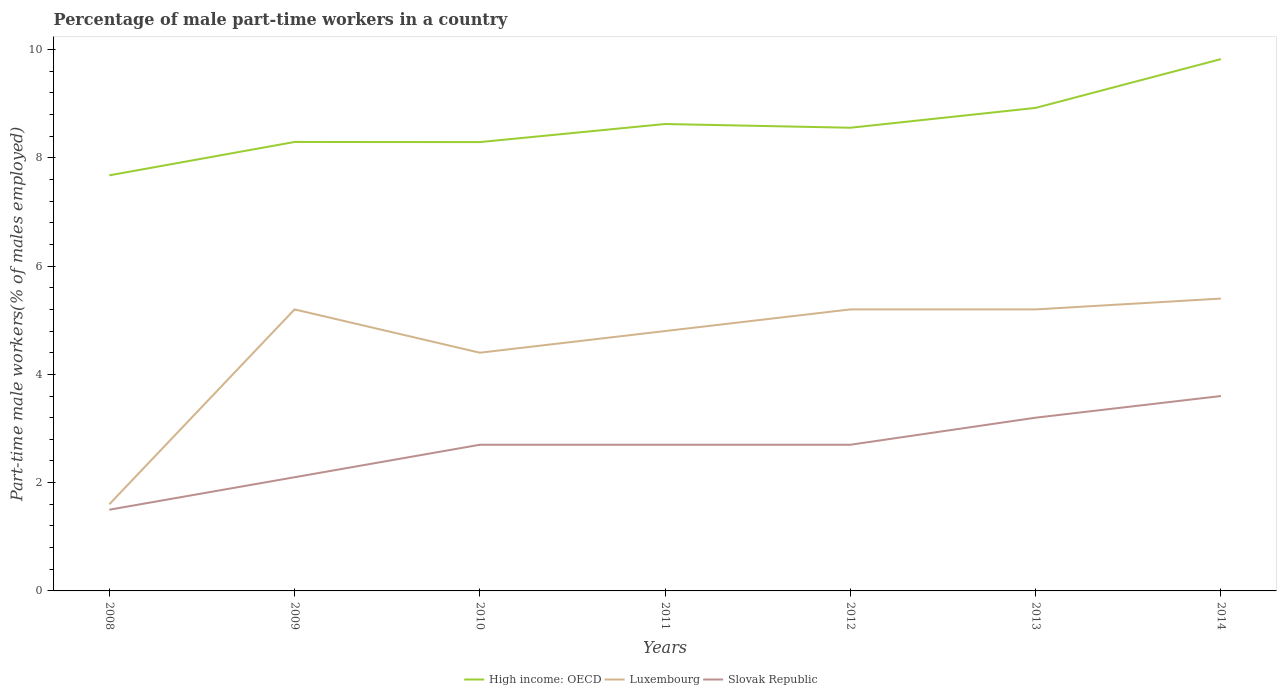Does the line corresponding to High income: OECD intersect with the line corresponding to Slovak Republic?
Your answer should be very brief. No. Is the number of lines equal to the number of legend labels?
Your response must be concise. Yes. Across all years, what is the maximum percentage of male part-time workers in Slovak Republic?
Give a very brief answer. 1.5. In which year was the percentage of male part-time workers in Luxembourg maximum?
Keep it short and to the point. 2008. What is the total percentage of male part-time workers in Luxembourg in the graph?
Your answer should be compact. -2.8. What is the difference between the highest and the second highest percentage of male part-time workers in High income: OECD?
Offer a terse response. 2.15. Is the percentage of male part-time workers in High income: OECD strictly greater than the percentage of male part-time workers in Luxembourg over the years?
Provide a succinct answer. No. How many lines are there?
Give a very brief answer. 3. What is the difference between two consecutive major ticks on the Y-axis?
Provide a short and direct response. 2. Are the values on the major ticks of Y-axis written in scientific E-notation?
Your response must be concise. No. Does the graph contain grids?
Make the answer very short. No. How are the legend labels stacked?
Ensure brevity in your answer.  Horizontal. What is the title of the graph?
Keep it short and to the point. Percentage of male part-time workers in a country. Does "Vietnam" appear as one of the legend labels in the graph?
Give a very brief answer. No. What is the label or title of the Y-axis?
Provide a short and direct response. Part-time male workers(% of males employed). What is the Part-time male workers(% of males employed) in High income: OECD in 2008?
Your response must be concise. 7.68. What is the Part-time male workers(% of males employed) of Luxembourg in 2008?
Provide a short and direct response. 1.6. What is the Part-time male workers(% of males employed) in Slovak Republic in 2008?
Your answer should be compact. 1.5. What is the Part-time male workers(% of males employed) of High income: OECD in 2009?
Your answer should be compact. 8.29. What is the Part-time male workers(% of males employed) of Luxembourg in 2009?
Keep it short and to the point. 5.2. What is the Part-time male workers(% of males employed) of Slovak Republic in 2009?
Your response must be concise. 2.1. What is the Part-time male workers(% of males employed) of High income: OECD in 2010?
Your answer should be very brief. 8.29. What is the Part-time male workers(% of males employed) in Luxembourg in 2010?
Ensure brevity in your answer.  4.4. What is the Part-time male workers(% of males employed) of Slovak Republic in 2010?
Provide a short and direct response. 2.7. What is the Part-time male workers(% of males employed) of High income: OECD in 2011?
Keep it short and to the point. 8.62. What is the Part-time male workers(% of males employed) of Luxembourg in 2011?
Your answer should be compact. 4.8. What is the Part-time male workers(% of males employed) in Slovak Republic in 2011?
Your answer should be compact. 2.7. What is the Part-time male workers(% of males employed) of High income: OECD in 2012?
Offer a very short reply. 8.56. What is the Part-time male workers(% of males employed) of Luxembourg in 2012?
Ensure brevity in your answer.  5.2. What is the Part-time male workers(% of males employed) in Slovak Republic in 2012?
Make the answer very short. 2.7. What is the Part-time male workers(% of males employed) of High income: OECD in 2013?
Your answer should be compact. 8.92. What is the Part-time male workers(% of males employed) of Luxembourg in 2013?
Ensure brevity in your answer.  5.2. What is the Part-time male workers(% of males employed) in Slovak Republic in 2013?
Offer a very short reply. 3.2. What is the Part-time male workers(% of males employed) of High income: OECD in 2014?
Provide a short and direct response. 9.82. What is the Part-time male workers(% of males employed) in Luxembourg in 2014?
Your response must be concise. 5.4. What is the Part-time male workers(% of males employed) in Slovak Republic in 2014?
Offer a very short reply. 3.6. Across all years, what is the maximum Part-time male workers(% of males employed) in High income: OECD?
Offer a terse response. 9.82. Across all years, what is the maximum Part-time male workers(% of males employed) in Luxembourg?
Give a very brief answer. 5.4. Across all years, what is the maximum Part-time male workers(% of males employed) of Slovak Republic?
Make the answer very short. 3.6. Across all years, what is the minimum Part-time male workers(% of males employed) in High income: OECD?
Your response must be concise. 7.68. Across all years, what is the minimum Part-time male workers(% of males employed) in Luxembourg?
Your answer should be very brief. 1.6. Across all years, what is the minimum Part-time male workers(% of males employed) in Slovak Republic?
Provide a succinct answer. 1.5. What is the total Part-time male workers(% of males employed) in High income: OECD in the graph?
Your answer should be compact. 60.19. What is the total Part-time male workers(% of males employed) in Luxembourg in the graph?
Provide a short and direct response. 31.8. What is the total Part-time male workers(% of males employed) in Slovak Republic in the graph?
Keep it short and to the point. 18.5. What is the difference between the Part-time male workers(% of males employed) in High income: OECD in 2008 and that in 2009?
Ensure brevity in your answer.  -0.62. What is the difference between the Part-time male workers(% of males employed) in Luxembourg in 2008 and that in 2009?
Your answer should be very brief. -3.6. What is the difference between the Part-time male workers(% of males employed) in High income: OECD in 2008 and that in 2010?
Make the answer very short. -0.61. What is the difference between the Part-time male workers(% of males employed) of Slovak Republic in 2008 and that in 2010?
Your answer should be compact. -1.2. What is the difference between the Part-time male workers(% of males employed) of High income: OECD in 2008 and that in 2011?
Your answer should be very brief. -0.95. What is the difference between the Part-time male workers(% of males employed) in Slovak Republic in 2008 and that in 2011?
Provide a short and direct response. -1.2. What is the difference between the Part-time male workers(% of males employed) of High income: OECD in 2008 and that in 2012?
Offer a terse response. -0.88. What is the difference between the Part-time male workers(% of males employed) in Luxembourg in 2008 and that in 2012?
Your response must be concise. -3.6. What is the difference between the Part-time male workers(% of males employed) of High income: OECD in 2008 and that in 2013?
Ensure brevity in your answer.  -1.25. What is the difference between the Part-time male workers(% of males employed) in High income: OECD in 2008 and that in 2014?
Keep it short and to the point. -2.15. What is the difference between the Part-time male workers(% of males employed) in High income: OECD in 2009 and that in 2010?
Offer a very short reply. 0. What is the difference between the Part-time male workers(% of males employed) in Luxembourg in 2009 and that in 2010?
Your answer should be very brief. 0.8. What is the difference between the Part-time male workers(% of males employed) of Slovak Republic in 2009 and that in 2010?
Offer a very short reply. -0.6. What is the difference between the Part-time male workers(% of males employed) in High income: OECD in 2009 and that in 2011?
Offer a terse response. -0.33. What is the difference between the Part-time male workers(% of males employed) of Luxembourg in 2009 and that in 2011?
Your response must be concise. 0.4. What is the difference between the Part-time male workers(% of males employed) of Slovak Republic in 2009 and that in 2011?
Provide a succinct answer. -0.6. What is the difference between the Part-time male workers(% of males employed) of High income: OECD in 2009 and that in 2012?
Ensure brevity in your answer.  -0.26. What is the difference between the Part-time male workers(% of males employed) of Luxembourg in 2009 and that in 2012?
Offer a terse response. 0. What is the difference between the Part-time male workers(% of males employed) of High income: OECD in 2009 and that in 2013?
Provide a succinct answer. -0.63. What is the difference between the Part-time male workers(% of males employed) of Slovak Republic in 2009 and that in 2013?
Offer a terse response. -1.1. What is the difference between the Part-time male workers(% of males employed) of High income: OECD in 2009 and that in 2014?
Your answer should be compact. -1.53. What is the difference between the Part-time male workers(% of males employed) in Slovak Republic in 2009 and that in 2014?
Provide a short and direct response. -1.5. What is the difference between the Part-time male workers(% of males employed) in High income: OECD in 2010 and that in 2011?
Provide a succinct answer. -0.33. What is the difference between the Part-time male workers(% of males employed) in Luxembourg in 2010 and that in 2011?
Your response must be concise. -0.4. What is the difference between the Part-time male workers(% of males employed) in Slovak Republic in 2010 and that in 2011?
Your answer should be very brief. 0. What is the difference between the Part-time male workers(% of males employed) in High income: OECD in 2010 and that in 2012?
Your answer should be compact. -0.27. What is the difference between the Part-time male workers(% of males employed) in Luxembourg in 2010 and that in 2012?
Offer a very short reply. -0.8. What is the difference between the Part-time male workers(% of males employed) of Slovak Republic in 2010 and that in 2012?
Keep it short and to the point. 0. What is the difference between the Part-time male workers(% of males employed) in High income: OECD in 2010 and that in 2013?
Offer a very short reply. -0.63. What is the difference between the Part-time male workers(% of males employed) in Slovak Republic in 2010 and that in 2013?
Your response must be concise. -0.5. What is the difference between the Part-time male workers(% of males employed) in High income: OECD in 2010 and that in 2014?
Your answer should be very brief. -1.53. What is the difference between the Part-time male workers(% of males employed) in Luxembourg in 2010 and that in 2014?
Give a very brief answer. -1. What is the difference between the Part-time male workers(% of males employed) of High income: OECD in 2011 and that in 2012?
Offer a very short reply. 0.07. What is the difference between the Part-time male workers(% of males employed) of High income: OECD in 2011 and that in 2013?
Offer a terse response. -0.3. What is the difference between the Part-time male workers(% of males employed) of High income: OECD in 2011 and that in 2014?
Keep it short and to the point. -1.2. What is the difference between the Part-time male workers(% of males employed) in Luxembourg in 2011 and that in 2014?
Offer a terse response. -0.6. What is the difference between the Part-time male workers(% of males employed) of High income: OECD in 2012 and that in 2013?
Offer a terse response. -0.37. What is the difference between the Part-time male workers(% of males employed) of Luxembourg in 2012 and that in 2013?
Provide a short and direct response. 0. What is the difference between the Part-time male workers(% of males employed) in Slovak Republic in 2012 and that in 2013?
Give a very brief answer. -0.5. What is the difference between the Part-time male workers(% of males employed) in High income: OECD in 2012 and that in 2014?
Your answer should be very brief. -1.27. What is the difference between the Part-time male workers(% of males employed) in Slovak Republic in 2012 and that in 2014?
Make the answer very short. -0.9. What is the difference between the Part-time male workers(% of males employed) in High income: OECD in 2013 and that in 2014?
Offer a terse response. -0.9. What is the difference between the Part-time male workers(% of males employed) in High income: OECD in 2008 and the Part-time male workers(% of males employed) in Luxembourg in 2009?
Your response must be concise. 2.48. What is the difference between the Part-time male workers(% of males employed) in High income: OECD in 2008 and the Part-time male workers(% of males employed) in Slovak Republic in 2009?
Offer a very short reply. 5.58. What is the difference between the Part-time male workers(% of males employed) in Luxembourg in 2008 and the Part-time male workers(% of males employed) in Slovak Republic in 2009?
Provide a short and direct response. -0.5. What is the difference between the Part-time male workers(% of males employed) in High income: OECD in 2008 and the Part-time male workers(% of males employed) in Luxembourg in 2010?
Ensure brevity in your answer.  3.28. What is the difference between the Part-time male workers(% of males employed) in High income: OECD in 2008 and the Part-time male workers(% of males employed) in Slovak Republic in 2010?
Ensure brevity in your answer.  4.98. What is the difference between the Part-time male workers(% of males employed) in High income: OECD in 2008 and the Part-time male workers(% of males employed) in Luxembourg in 2011?
Your answer should be compact. 2.88. What is the difference between the Part-time male workers(% of males employed) in High income: OECD in 2008 and the Part-time male workers(% of males employed) in Slovak Republic in 2011?
Offer a very short reply. 4.98. What is the difference between the Part-time male workers(% of males employed) in Luxembourg in 2008 and the Part-time male workers(% of males employed) in Slovak Republic in 2011?
Your answer should be very brief. -1.1. What is the difference between the Part-time male workers(% of males employed) of High income: OECD in 2008 and the Part-time male workers(% of males employed) of Luxembourg in 2012?
Give a very brief answer. 2.48. What is the difference between the Part-time male workers(% of males employed) of High income: OECD in 2008 and the Part-time male workers(% of males employed) of Slovak Republic in 2012?
Your response must be concise. 4.98. What is the difference between the Part-time male workers(% of males employed) in High income: OECD in 2008 and the Part-time male workers(% of males employed) in Luxembourg in 2013?
Ensure brevity in your answer.  2.48. What is the difference between the Part-time male workers(% of males employed) in High income: OECD in 2008 and the Part-time male workers(% of males employed) in Slovak Republic in 2013?
Your answer should be compact. 4.48. What is the difference between the Part-time male workers(% of males employed) of Luxembourg in 2008 and the Part-time male workers(% of males employed) of Slovak Republic in 2013?
Keep it short and to the point. -1.6. What is the difference between the Part-time male workers(% of males employed) of High income: OECD in 2008 and the Part-time male workers(% of males employed) of Luxembourg in 2014?
Give a very brief answer. 2.28. What is the difference between the Part-time male workers(% of males employed) of High income: OECD in 2008 and the Part-time male workers(% of males employed) of Slovak Republic in 2014?
Your answer should be very brief. 4.08. What is the difference between the Part-time male workers(% of males employed) in Luxembourg in 2008 and the Part-time male workers(% of males employed) in Slovak Republic in 2014?
Ensure brevity in your answer.  -2. What is the difference between the Part-time male workers(% of males employed) in High income: OECD in 2009 and the Part-time male workers(% of males employed) in Luxembourg in 2010?
Give a very brief answer. 3.89. What is the difference between the Part-time male workers(% of males employed) of High income: OECD in 2009 and the Part-time male workers(% of males employed) of Slovak Republic in 2010?
Give a very brief answer. 5.59. What is the difference between the Part-time male workers(% of males employed) in High income: OECD in 2009 and the Part-time male workers(% of males employed) in Luxembourg in 2011?
Keep it short and to the point. 3.49. What is the difference between the Part-time male workers(% of males employed) of High income: OECD in 2009 and the Part-time male workers(% of males employed) of Slovak Republic in 2011?
Give a very brief answer. 5.59. What is the difference between the Part-time male workers(% of males employed) of Luxembourg in 2009 and the Part-time male workers(% of males employed) of Slovak Republic in 2011?
Keep it short and to the point. 2.5. What is the difference between the Part-time male workers(% of males employed) of High income: OECD in 2009 and the Part-time male workers(% of males employed) of Luxembourg in 2012?
Provide a succinct answer. 3.09. What is the difference between the Part-time male workers(% of males employed) in High income: OECD in 2009 and the Part-time male workers(% of males employed) in Slovak Republic in 2012?
Keep it short and to the point. 5.59. What is the difference between the Part-time male workers(% of males employed) in Luxembourg in 2009 and the Part-time male workers(% of males employed) in Slovak Republic in 2012?
Provide a succinct answer. 2.5. What is the difference between the Part-time male workers(% of males employed) of High income: OECD in 2009 and the Part-time male workers(% of males employed) of Luxembourg in 2013?
Provide a succinct answer. 3.09. What is the difference between the Part-time male workers(% of males employed) of High income: OECD in 2009 and the Part-time male workers(% of males employed) of Slovak Republic in 2013?
Provide a short and direct response. 5.09. What is the difference between the Part-time male workers(% of males employed) of Luxembourg in 2009 and the Part-time male workers(% of males employed) of Slovak Republic in 2013?
Provide a succinct answer. 2. What is the difference between the Part-time male workers(% of males employed) of High income: OECD in 2009 and the Part-time male workers(% of males employed) of Luxembourg in 2014?
Your response must be concise. 2.89. What is the difference between the Part-time male workers(% of males employed) of High income: OECD in 2009 and the Part-time male workers(% of males employed) of Slovak Republic in 2014?
Offer a terse response. 4.69. What is the difference between the Part-time male workers(% of males employed) of Luxembourg in 2009 and the Part-time male workers(% of males employed) of Slovak Republic in 2014?
Your response must be concise. 1.6. What is the difference between the Part-time male workers(% of males employed) of High income: OECD in 2010 and the Part-time male workers(% of males employed) of Luxembourg in 2011?
Your answer should be very brief. 3.49. What is the difference between the Part-time male workers(% of males employed) of High income: OECD in 2010 and the Part-time male workers(% of males employed) of Slovak Republic in 2011?
Give a very brief answer. 5.59. What is the difference between the Part-time male workers(% of males employed) of High income: OECD in 2010 and the Part-time male workers(% of males employed) of Luxembourg in 2012?
Keep it short and to the point. 3.09. What is the difference between the Part-time male workers(% of males employed) in High income: OECD in 2010 and the Part-time male workers(% of males employed) in Slovak Republic in 2012?
Your response must be concise. 5.59. What is the difference between the Part-time male workers(% of males employed) in Luxembourg in 2010 and the Part-time male workers(% of males employed) in Slovak Republic in 2012?
Give a very brief answer. 1.7. What is the difference between the Part-time male workers(% of males employed) in High income: OECD in 2010 and the Part-time male workers(% of males employed) in Luxembourg in 2013?
Ensure brevity in your answer.  3.09. What is the difference between the Part-time male workers(% of males employed) of High income: OECD in 2010 and the Part-time male workers(% of males employed) of Slovak Republic in 2013?
Keep it short and to the point. 5.09. What is the difference between the Part-time male workers(% of males employed) in High income: OECD in 2010 and the Part-time male workers(% of males employed) in Luxembourg in 2014?
Give a very brief answer. 2.89. What is the difference between the Part-time male workers(% of males employed) in High income: OECD in 2010 and the Part-time male workers(% of males employed) in Slovak Republic in 2014?
Offer a terse response. 4.69. What is the difference between the Part-time male workers(% of males employed) in Luxembourg in 2010 and the Part-time male workers(% of males employed) in Slovak Republic in 2014?
Make the answer very short. 0.8. What is the difference between the Part-time male workers(% of males employed) of High income: OECD in 2011 and the Part-time male workers(% of males employed) of Luxembourg in 2012?
Ensure brevity in your answer.  3.42. What is the difference between the Part-time male workers(% of males employed) of High income: OECD in 2011 and the Part-time male workers(% of males employed) of Slovak Republic in 2012?
Your answer should be compact. 5.92. What is the difference between the Part-time male workers(% of males employed) in Luxembourg in 2011 and the Part-time male workers(% of males employed) in Slovak Republic in 2012?
Make the answer very short. 2.1. What is the difference between the Part-time male workers(% of males employed) in High income: OECD in 2011 and the Part-time male workers(% of males employed) in Luxembourg in 2013?
Give a very brief answer. 3.42. What is the difference between the Part-time male workers(% of males employed) of High income: OECD in 2011 and the Part-time male workers(% of males employed) of Slovak Republic in 2013?
Your answer should be very brief. 5.42. What is the difference between the Part-time male workers(% of males employed) of Luxembourg in 2011 and the Part-time male workers(% of males employed) of Slovak Republic in 2013?
Provide a succinct answer. 1.6. What is the difference between the Part-time male workers(% of males employed) of High income: OECD in 2011 and the Part-time male workers(% of males employed) of Luxembourg in 2014?
Offer a very short reply. 3.22. What is the difference between the Part-time male workers(% of males employed) in High income: OECD in 2011 and the Part-time male workers(% of males employed) in Slovak Republic in 2014?
Your answer should be compact. 5.02. What is the difference between the Part-time male workers(% of males employed) of High income: OECD in 2012 and the Part-time male workers(% of males employed) of Luxembourg in 2013?
Your answer should be very brief. 3.36. What is the difference between the Part-time male workers(% of males employed) in High income: OECD in 2012 and the Part-time male workers(% of males employed) in Slovak Republic in 2013?
Provide a short and direct response. 5.36. What is the difference between the Part-time male workers(% of males employed) of Luxembourg in 2012 and the Part-time male workers(% of males employed) of Slovak Republic in 2013?
Provide a short and direct response. 2. What is the difference between the Part-time male workers(% of males employed) in High income: OECD in 2012 and the Part-time male workers(% of males employed) in Luxembourg in 2014?
Your answer should be compact. 3.16. What is the difference between the Part-time male workers(% of males employed) of High income: OECD in 2012 and the Part-time male workers(% of males employed) of Slovak Republic in 2014?
Ensure brevity in your answer.  4.96. What is the difference between the Part-time male workers(% of males employed) of High income: OECD in 2013 and the Part-time male workers(% of males employed) of Luxembourg in 2014?
Provide a short and direct response. 3.52. What is the difference between the Part-time male workers(% of males employed) in High income: OECD in 2013 and the Part-time male workers(% of males employed) in Slovak Republic in 2014?
Make the answer very short. 5.32. What is the average Part-time male workers(% of males employed) in High income: OECD per year?
Offer a very short reply. 8.6. What is the average Part-time male workers(% of males employed) of Luxembourg per year?
Your answer should be very brief. 4.54. What is the average Part-time male workers(% of males employed) in Slovak Republic per year?
Provide a short and direct response. 2.64. In the year 2008, what is the difference between the Part-time male workers(% of males employed) in High income: OECD and Part-time male workers(% of males employed) in Luxembourg?
Your answer should be compact. 6.08. In the year 2008, what is the difference between the Part-time male workers(% of males employed) in High income: OECD and Part-time male workers(% of males employed) in Slovak Republic?
Offer a very short reply. 6.18. In the year 2009, what is the difference between the Part-time male workers(% of males employed) of High income: OECD and Part-time male workers(% of males employed) of Luxembourg?
Keep it short and to the point. 3.09. In the year 2009, what is the difference between the Part-time male workers(% of males employed) in High income: OECD and Part-time male workers(% of males employed) in Slovak Republic?
Offer a terse response. 6.19. In the year 2009, what is the difference between the Part-time male workers(% of males employed) in Luxembourg and Part-time male workers(% of males employed) in Slovak Republic?
Give a very brief answer. 3.1. In the year 2010, what is the difference between the Part-time male workers(% of males employed) in High income: OECD and Part-time male workers(% of males employed) in Luxembourg?
Your answer should be compact. 3.89. In the year 2010, what is the difference between the Part-time male workers(% of males employed) of High income: OECD and Part-time male workers(% of males employed) of Slovak Republic?
Offer a terse response. 5.59. In the year 2010, what is the difference between the Part-time male workers(% of males employed) of Luxembourg and Part-time male workers(% of males employed) of Slovak Republic?
Your answer should be very brief. 1.7. In the year 2011, what is the difference between the Part-time male workers(% of males employed) in High income: OECD and Part-time male workers(% of males employed) in Luxembourg?
Your answer should be compact. 3.82. In the year 2011, what is the difference between the Part-time male workers(% of males employed) of High income: OECD and Part-time male workers(% of males employed) of Slovak Republic?
Your response must be concise. 5.92. In the year 2011, what is the difference between the Part-time male workers(% of males employed) of Luxembourg and Part-time male workers(% of males employed) of Slovak Republic?
Ensure brevity in your answer.  2.1. In the year 2012, what is the difference between the Part-time male workers(% of males employed) of High income: OECD and Part-time male workers(% of males employed) of Luxembourg?
Your response must be concise. 3.36. In the year 2012, what is the difference between the Part-time male workers(% of males employed) of High income: OECD and Part-time male workers(% of males employed) of Slovak Republic?
Your response must be concise. 5.86. In the year 2012, what is the difference between the Part-time male workers(% of males employed) of Luxembourg and Part-time male workers(% of males employed) of Slovak Republic?
Make the answer very short. 2.5. In the year 2013, what is the difference between the Part-time male workers(% of males employed) in High income: OECD and Part-time male workers(% of males employed) in Luxembourg?
Your answer should be compact. 3.72. In the year 2013, what is the difference between the Part-time male workers(% of males employed) in High income: OECD and Part-time male workers(% of males employed) in Slovak Republic?
Offer a terse response. 5.72. In the year 2013, what is the difference between the Part-time male workers(% of males employed) in Luxembourg and Part-time male workers(% of males employed) in Slovak Republic?
Ensure brevity in your answer.  2. In the year 2014, what is the difference between the Part-time male workers(% of males employed) of High income: OECD and Part-time male workers(% of males employed) of Luxembourg?
Offer a very short reply. 4.42. In the year 2014, what is the difference between the Part-time male workers(% of males employed) of High income: OECD and Part-time male workers(% of males employed) of Slovak Republic?
Offer a terse response. 6.22. In the year 2014, what is the difference between the Part-time male workers(% of males employed) in Luxembourg and Part-time male workers(% of males employed) in Slovak Republic?
Your response must be concise. 1.8. What is the ratio of the Part-time male workers(% of males employed) of High income: OECD in 2008 to that in 2009?
Your response must be concise. 0.93. What is the ratio of the Part-time male workers(% of males employed) in Luxembourg in 2008 to that in 2009?
Keep it short and to the point. 0.31. What is the ratio of the Part-time male workers(% of males employed) in High income: OECD in 2008 to that in 2010?
Offer a very short reply. 0.93. What is the ratio of the Part-time male workers(% of males employed) in Luxembourg in 2008 to that in 2010?
Keep it short and to the point. 0.36. What is the ratio of the Part-time male workers(% of males employed) in Slovak Republic in 2008 to that in 2010?
Offer a terse response. 0.56. What is the ratio of the Part-time male workers(% of males employed) in High income: OECD in 2008 to that in 2011?
Offer a very short reply. 0.89. What is the ratio of the Part-time male workers(% of males employed) in Luxembourg in 2008 to that in 2011?
Ensure brevity in your answer.  0.33. What is the ratio of the Part-time male workers(% of males employed) of Slovak Republic in 2008 to that in 2011?
Your answer should be very brief. 0.56. What is the ratio of the Part-time male workers(% of males employed) in High income: OECD in 2008 to that in 2012?
Offer a terse response. 0.9. What is the ratio of the Part-time male workers(% of males employed) of Luxembourg in 2008 to that in 2012?
Your response must be concise. 0.31. What is the ratio of the Part-time male workers(% of males employed) of Slovak Republic in 2008 to that in 2012?
Your answer should be compact. 0.56. What is the ratio of the Part-time male workers(% of males employed) of High income: OECD in 2008 to that in 2013?
Ensure brevity in your answer.  0.86. What is the ratio of the Part-time male workers(% of males employed) of Luxembourg in 2008 to that in 2013?
Ensure brevity in your answer.  0.31. What is the ratio of the Part-time male workers(% of males employed) of Slovak Republic in 2008 to that in 2013?
Provide a succinct answer. 0.47. What is the ratio of the Part-time male workers(% of males employed) of High income: OECD in 2008 to that in 2014?
Your answer should be very brief. 0.78. What is the ratio of the Part-time male workers(% of males employed) in Luxembourg in 2008 to that in 2014?
Make the answer very short. 0.3. What is the ratio of the Part-time male workers(% of males employed) in Slovak Republic in 2008 to that in 2014?
Ensure brevity in your answer.  0.42. What is the ratio of the Part-time male workers(% of males employed) of Luxembourg in 2009 to that in 2010?
Ensure brevity in your answer.  1.18. What is the ratio of the Part-time male workers(% of males employed) in High income: OECD in 2009 to that in 2011?
Provide a short and direct response. 0.96. What is the ratio of the Part-time male workers(% of males employed) of Slovak Republic in 2009 to that in 2011?
Your answer should be compact. 0.78. What is the ratio of the Part-time male workers(% of males employed) in High income: OECD in 2009 to that in 2012?
Keep it short and to the point. 0.97. What is the ratio of the Part-time male workers(% of males employed) of High income: OECD in 2009 to that in 2013?
Your answer should be compact. 0.93. What is the ratio of the Part-time male workers(% of males employed) in Slovak Republic in 2009 to that in 2013?
Provide a succinct answer. 0.66. What is the ratio of the Part-time male workers(% of males employed) in High income: OECD in 2009 to that in 2014?
Your response must be concise. 0.84. What is the ratio of the Part-time male workers(% of males employed) in Slovak Republic in 2009 to that in 2014?
Give a very brief answer. 0.58. What is the ratio of the Part-time male workers(% of males employed) in High income: OECD in 2010 to that in 2011?
Your response must be concise. 0.96. What is the ratio of the Part-time male workers(% of males employed) in Luxembourg in 2010 to that in 2011?
Offer a very short reply. 0.92. What is the ratio of the Part-time male workers(% of males employed) of Slovak Republic in 2010 to that in 2011?
Provide a short and direct response. 1. What is the ratio of the Part-time male workers(% of males employed) of Luxembourg in 2010 to that in 2012?
Ensure brevity in your answer.  0.85. What is the ratio of the Part-time male workers(% of males employed) in Slovak Republic in 2010 to that in 2012?
Keep it short and to the point. 1. What is the ratio of the Part-time male workers(% of males employed) of High income: OECD in 2010 to that in 2013?
Keep it short and to the point. 0.93. What is the ratio of the Part-time male workers(% of males employed) of Luxembourg in 2010 to that in 2013?
Offer a terse response. 0.85. What is the ratio of the Part-time male workers(% of males employed) in Slovak Republic in 2010 to that in 2013?
Your response must be concise. 0.84. What is the ratio of the Part-time male workers(% of males employed) in High income: OECD in 2010 to that in 2014?
Make the answer very short. 0.84. What is the ratio of the Part-time male workers(% of males employed) of Luxembourg in 2010 to that in 2014?
Provide a succinct answer. 0.81. What is the ratio of the Part-time male workers(% of males employed) of High income: OECD in 2011 to that in 2012?
Your answer should be compact. 1.01. What is the ratio of the Part-time male workers(% of males employed) of Luxembourg in 2011 to that in 2012?
Ensure brevity in your answer.  0.92. What is the ratio of the Part-time male workers(% of males employed) in Slovak Republic in 2011 to that in 2012?
Make the answer very short. 1. What is the ratio of the Part-time male workers(% of males employed) of High income: OECD in 2011 to that in 2013?
Your answer should be very brief. 0.97. What is the ratio of the Part-time male workers(% of males employed) of Luxembourg in 2011 to that in 2013?
Provide a succinct answer. 0.92. What is the ratio of the Part-time male workers(% of males employed) of Slovak Republic in 2011 to that in 2013?
Ensure brevity in your answer.  0.84. What is the ratio of the Part-time male workers(% of males employed) of High income: OECD in 2011 to that in 2014?
Offer a terse response. 0.88. What is the ratio of the Part-time male workers(% of males employed) in Luxembourg in 2011 to that in 2014?
Give a very brief answer. 0.89. What is the ratio of the Part-time male workers(% of males employed) in Slovak Republic in 2011 to that in 2014?
Make the answer very short. 0.75. What is the ratio of the Part-time male workers(% of males employed) of High income: OECD in 2012 to that in 2013?
Give a very brief answer. 0.96. What is the ratio of the Part-time male workers(% of males employed) in Slovak Republic in 2012 to that in 2013?
Keep it short and to the point. 0.84. What is the ratio of the Part-time male workers(% of males employed) of High income: OECD in 2012 to that in 2014?
Your answer should be compact. 0.87. What is the ratio of the Part-time male workers(% of males employed) of High income: OECD in 2013 to that in 2014?
Keep it short and to the point. 0.91. What is the ratio of the Part-time male workers(% of males employed) of Luxembourg in 2013 to that in 2014?
Provide a succinct answer. 0.96. What is the difference between the highest and the second highest Part-time male workers(% of males employed) of High income: OECD?
Give a very brief answer. 0.9. What is the difference between the highest and the lowest Part-time male workers(% of males employed) of High income: OECD?
Give a very brief answer. 2.15. 